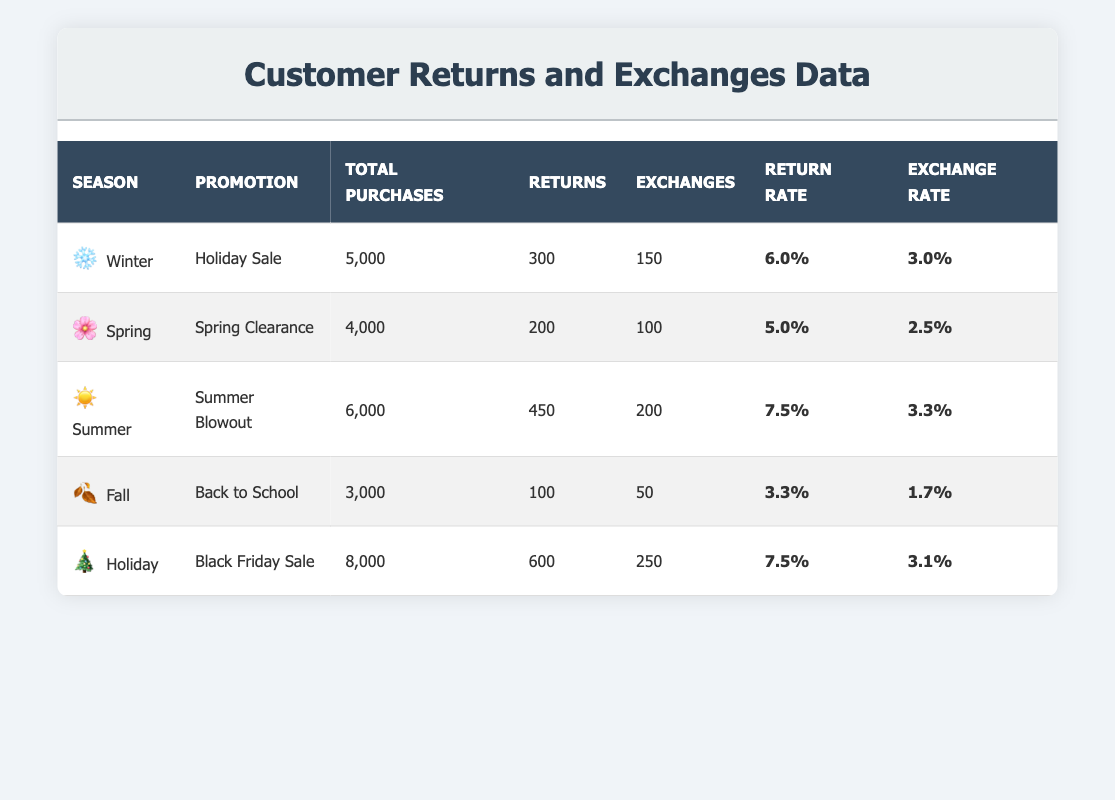What was the return rate for the Summer Blowout promotion? The return rate for the Summer Blowout promotion is specifically listed in the table under the Return Rate column for Summer. It shows a return rate of 7.5%.
Answer: 7.5% Which season had the highest number of exchanges? To find the highest number of exchanges, we compare the Exchange column across all seasons. The data for Holiday shows 250 exchanges, which is more than any other season.
Answer: Holiday What is the total number of purchases for Spring and Fall combined? The total purchases for Spring is 4,000 and for Fall is 3,000. Adding these two numbers gives us 4,000 + 3,000 = 7,000 total purchases for Spring and Fall combined.
Answer: 7,000 Was the return rate during the Holiday promotion higher than that during the Winter promotion? The return rate for Holiday is 7.5%, while for Winter it is 6.0%. Since 7.5% is greater than 6.0%, we can conclude that the return rate during the Holiday promotion was higher.
Answer: Yes What is the average exchange rate across all promotions? To find the average exchange rate, we sum the exchange rates of all promotions (3.0 + 2.5 + 3.3 + 1.7 + 3.1 = 13.6) and then divide by the number of promotions (5). So, 13.6 / 5 = 2.72 is the average exchange rate.
Answer: 2.72 Which season had the lowest return rate and what was it? To find the lowest return rate, we look at the Return Rate column. The Fall season has a return rate of 3.3%, which is lower than any other season’s return rate.
Answer: Fall, 3.3% What is the difference in return rates between the Black Friday Sale and Spring Clearance promotions? The return rate for the Black Friday Sale is 7.5%, and for Spring Clearance, it is 5.0%. The difference is calculated as 7.5% - 5.0% = 2.5%.
Answer: 2.5% Did the Summer promotion have a higher return rate than the Fall promotion? The return rate for the Summer promotion is 7.5%, while for Fall it is 3.3%. Since 7.5% is greater than 3.3%, the Summer promotion had a higher return rate.
Answer: Yes What is the total number of returns across all seasons? To find the total number of returns, we sum all the returns from each promotion (300 + 200 + 450 + 100 + 600 = 1,650).
Answer: 1,650 